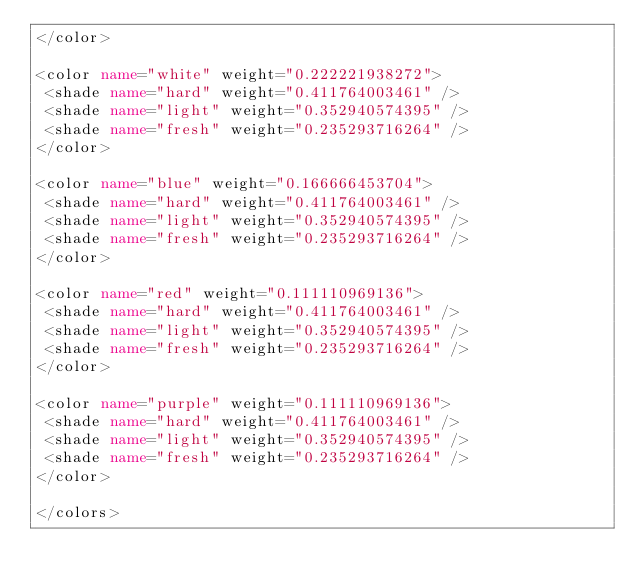Convert code to text. <code><loc_0><loc_0><loc_500><loc_500><_XML_></color>

<color name="white" weight="0.222221938272">
 <shade name="hard" weight="0.411764003461" />
 <shade name="light" weight="0.352940574395" />
 <shade name="fresh" weight="0.235293716264" />
</color>

<color name="blue" weight="0.166666453704">
 <shade name="hard" weight="0.411764003461" />
 <shade name="light" weight="0.352940574395" />
 <shade name="fresh" weight="0.235293716264" />
</color>

<color name="red" weight="0.111110969136">
 <shade name="hard" weight="0.411764003461" />
 <shade name="light" weight="0.352940574395" />
 <shade name="fresh" weight="0.235293716264" />
</color>

<color name="purple" weight="0.111110969136">
 <shade name="hard" weight="0.411764003461" />
 <shade name="light" weight="0.352940574395" />
 <shade name="fresh" weight="0.235293716264" />
</color>

</colors></code> 